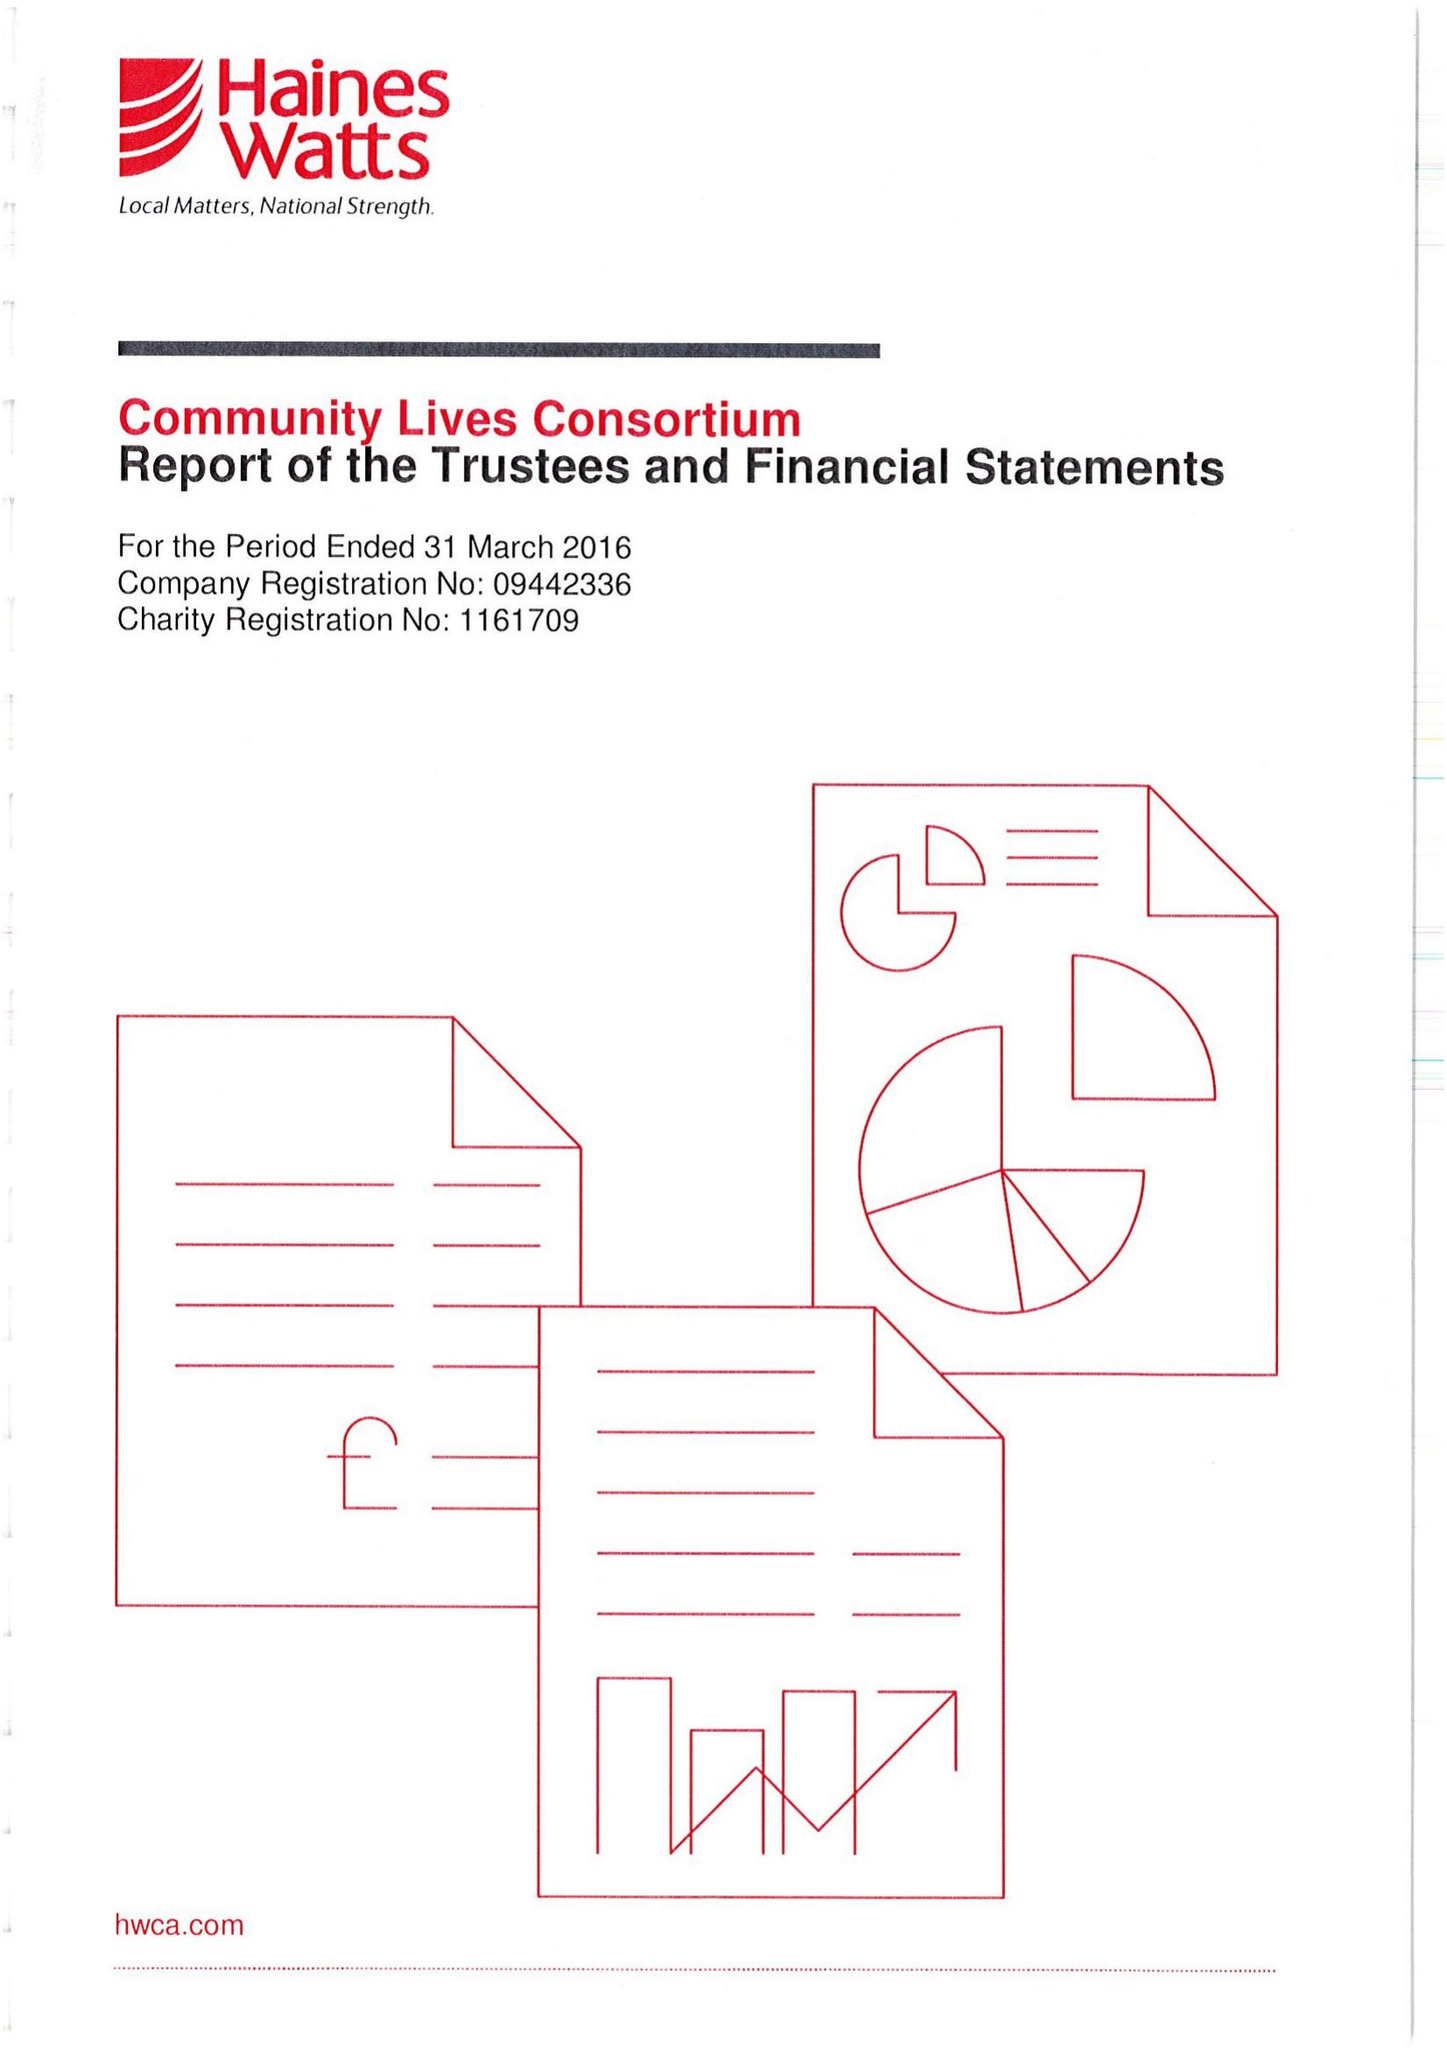What is the value for the address__postcode?
Answer the question using a single word or phrase. SA1 5NN 